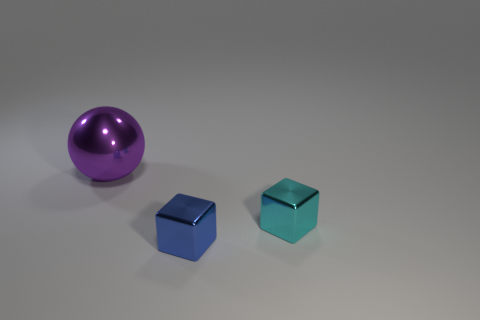What materials appear to be represented by the objects in the image? The objects in the image seem to be represented by different materials. The large ball on the left appears to be metallic with a reflective, shiny surface, implying it could be made of a polished metal. The two cubes in the center and right look like they are made of a translucent material with a slightly reflective surface, possibly glass or a plastic with a similar visual quality. 